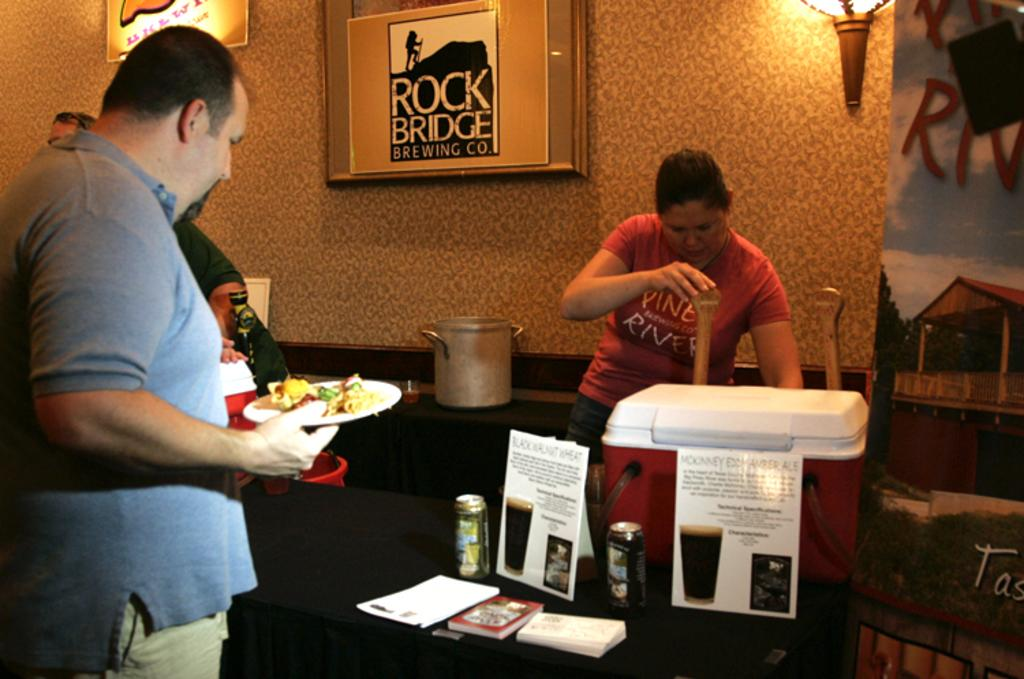<image>
Write a terse but informative summary of the picture. Someone serving food and drink with a Rock Bridge Brewing Co poster behind them. 